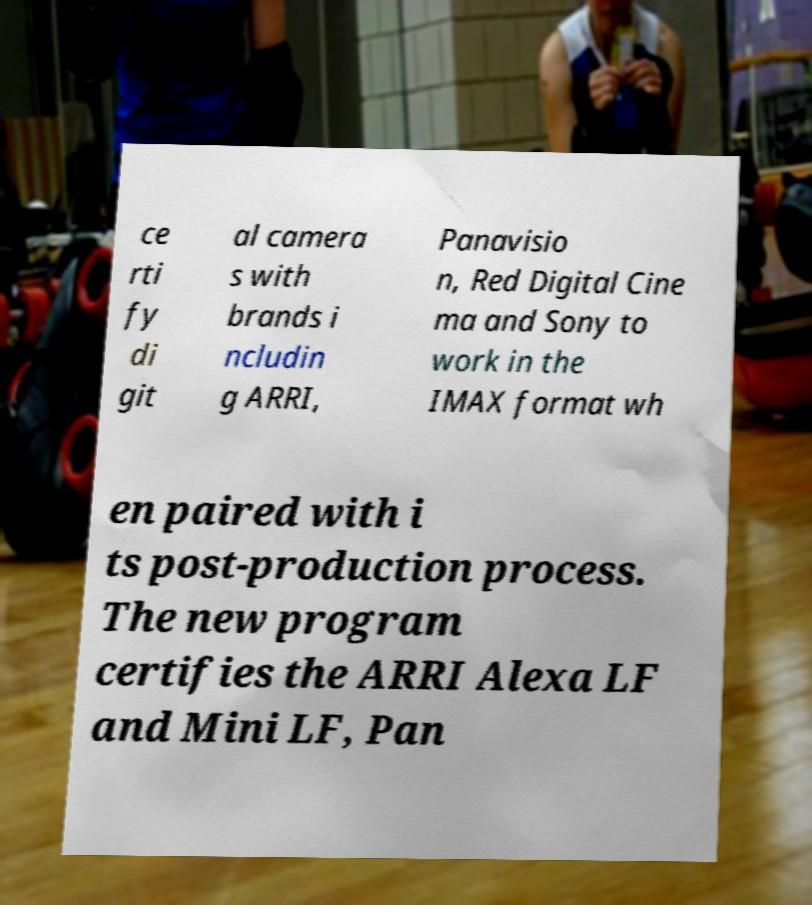Please read and relay the text visible in this image. What does it say? ce rti fy di git al camera s with brands i ncludin g ARRI, Panavisio n, Red Digital Cine ma and Sony to work in the IMAX format wh en paired with i ts post-production process. The new program certifies the ARRI Alexa LF and Mini LF, Pan 